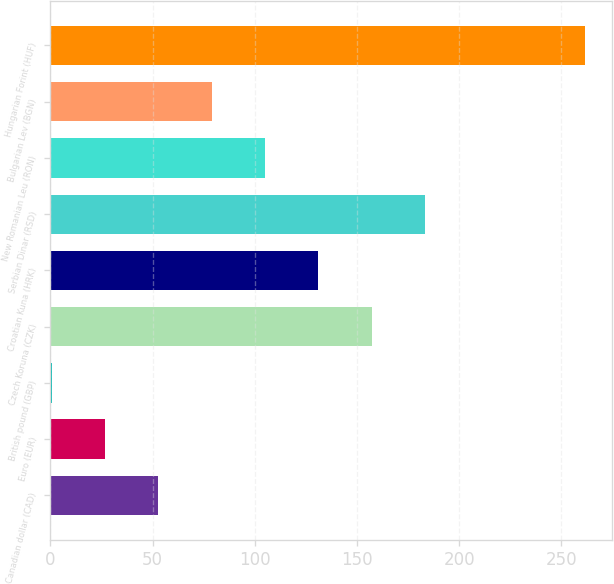<chart> <loc_0><loc_0><loc_500><loc_500><bar_chart><fcel>Canadian dollar (CAD)<fcel>Euro (EUR)<fcel>British pound (GBP)<fcel>Czech Koruna (CZK)<fcel>Croatian Kuna (HRK)<fcel>Serbian Dinar (RSD)<fcel>New Romanian Leu (RON)<fcel>Bulgarian Lev (BGN)<fcel>Hungarian Forint (HUF)<nl><fcel>52.84<fcel>26.74<fcel>0.64<fcel>157.24<fcel>131.14<fcel>183.34<fcel>105.04<fcel>78.94<fcel>261.64<nl></chart> 